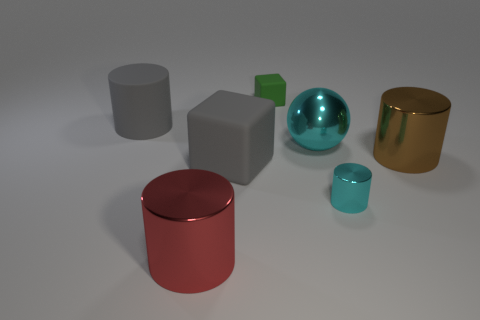Is the color of the big ball the same as the big metal cylinder left of the green cube?
Give a very brief answer. No. What size is the red metal thing that is the same shape as the brown metallic thing?
Keep it short and to the point. Large. What is the shape of the rubber thing that is both in front of the tiny green block and to the right of the gray cylinder?
Make the answer very short. Cube. Do the gray cylinder and the metal thing that is on the left side of the small rubber object have the same size?
Offer a very short reply. Yes. There is a rubber thing that is the same shape as the tiny metallic object; what color is it?
Provide a succinct answer. Gray. Do the matte object that is in front of the big gray matte cylinder and the shiny thing that is to the left of the small cube have the same size?
Offer a terse response. Yes. Is the big red object the same shape as the large brown thing?
Offer a terse response. Yes. What number of things are either gray things behind the brown object or brown objects?
Your response must be concise. 2. Is there another red metallic thing that has the same shape as the red shiny object?
Ensure brevity in your answer.  No. Is the number of tiny matte objects that are right of the tiny cyan metal cylinder the same as the number of gray matte objects?
Offer a terse response. No. 